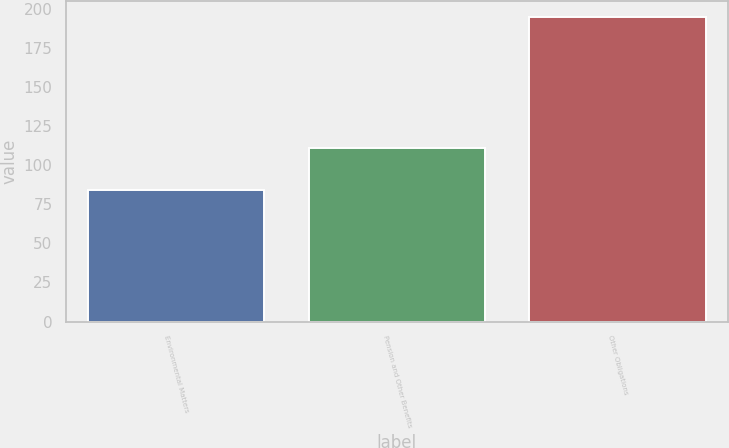Convert chart. <chart><loc_0><loc_0><loc_500><loc_500><bar_chart><fcel>Environmental Matters<fcel>Pension and Other Benefits<fcel>Other Obligations<nl><fcel>84<fcel>111<fcel>195<nl></chart> 